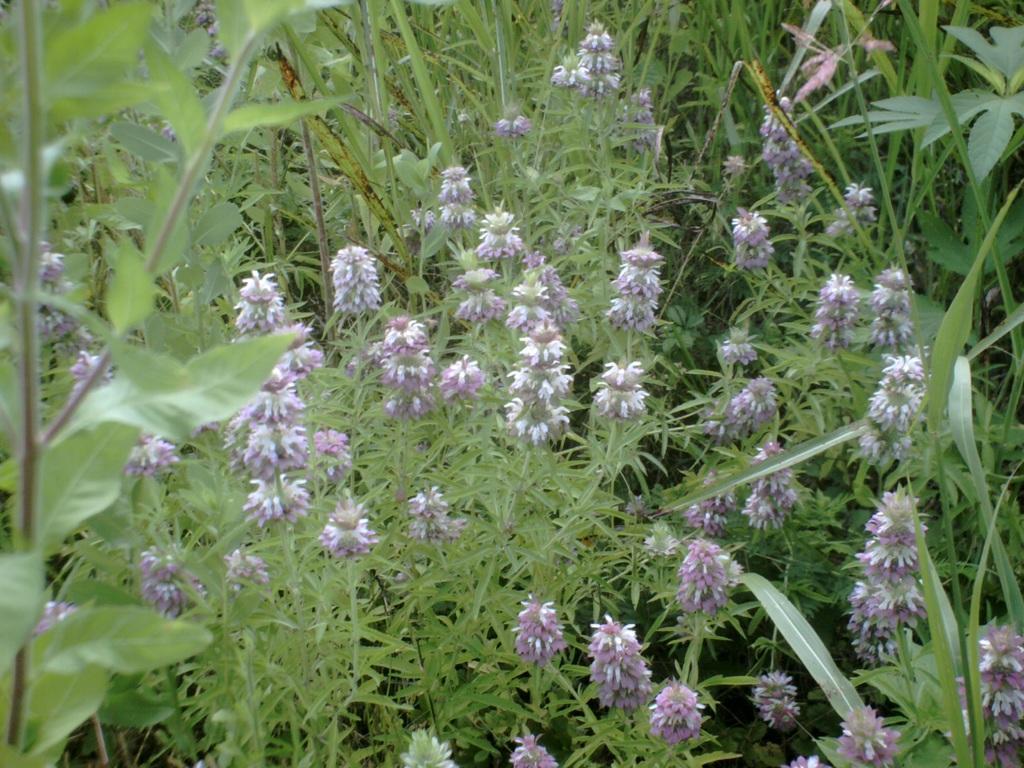Could you give a brief overview of what you see in this image? Here we can see planets on the ground with flowers. 